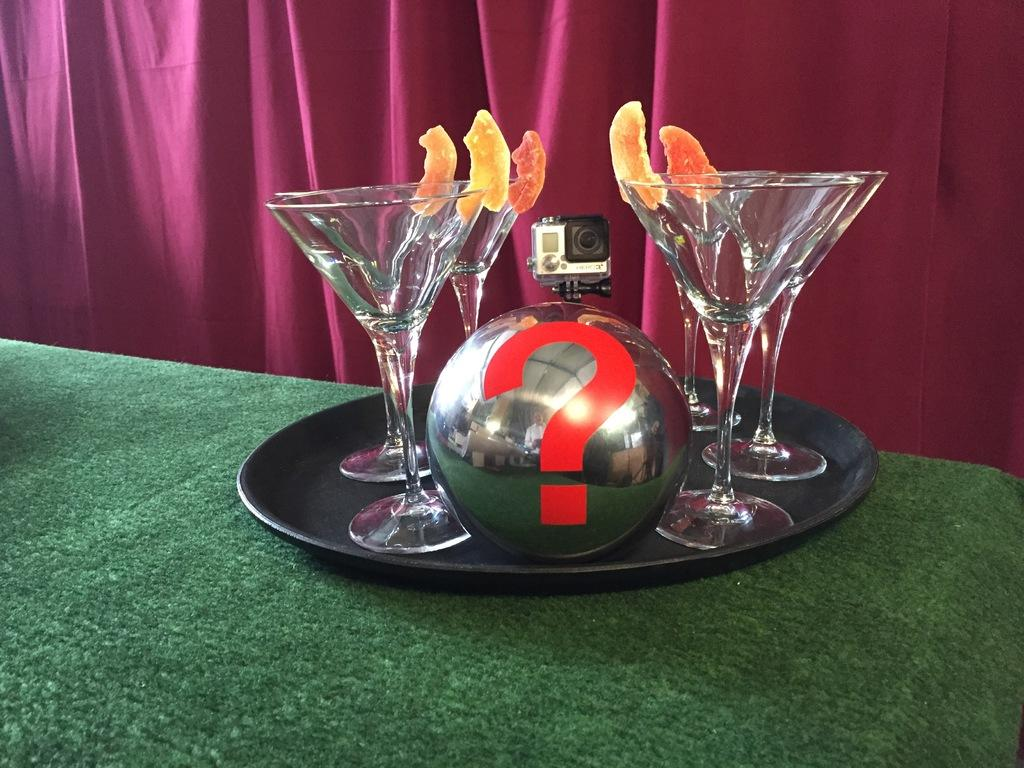What type of objects can be seen on the table in the image? There are glasses, a camera, and a ball in a plate on the table in the image. What is the purpose of the camera in the image? The purpose of the camera is to capture images or videos. What is the position of the ball in the image? The ball is in a plate in the image. What can be seen in the background of the image? There is a curtain in the background of the image. What is the order of the objects on the table, from left to right? The provided facts do not specify the order of the objects on the table, so it cannot be determined from the image. 